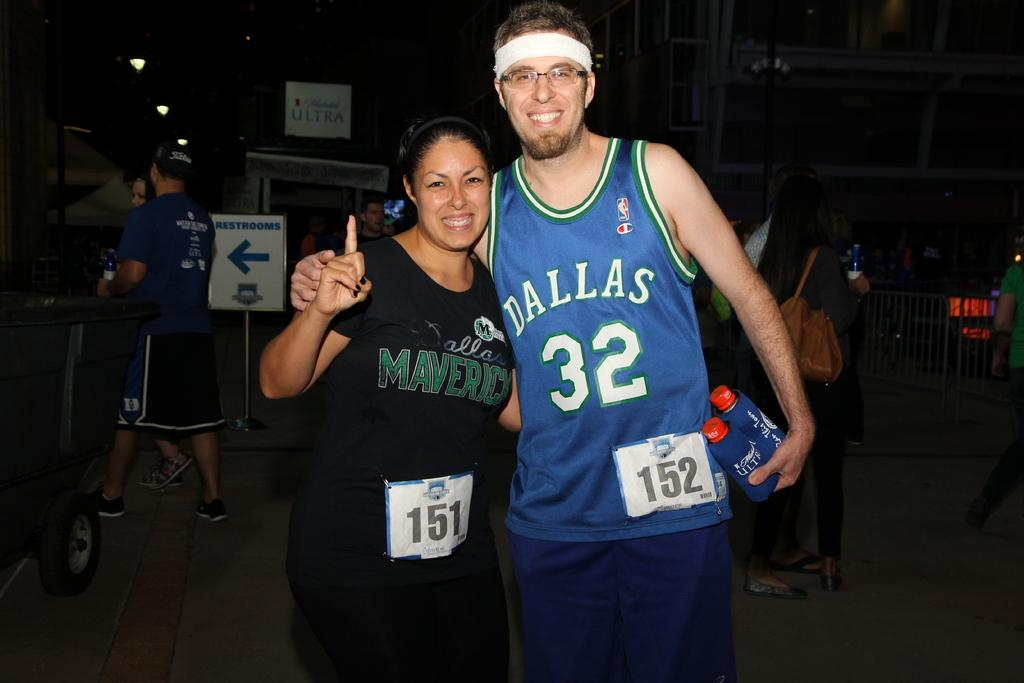<image>
Give a short and clear explanation of the subsequent image. A man in a blue #32 Dallas jersey is next to a woman wearing a Mavericks shirt. 